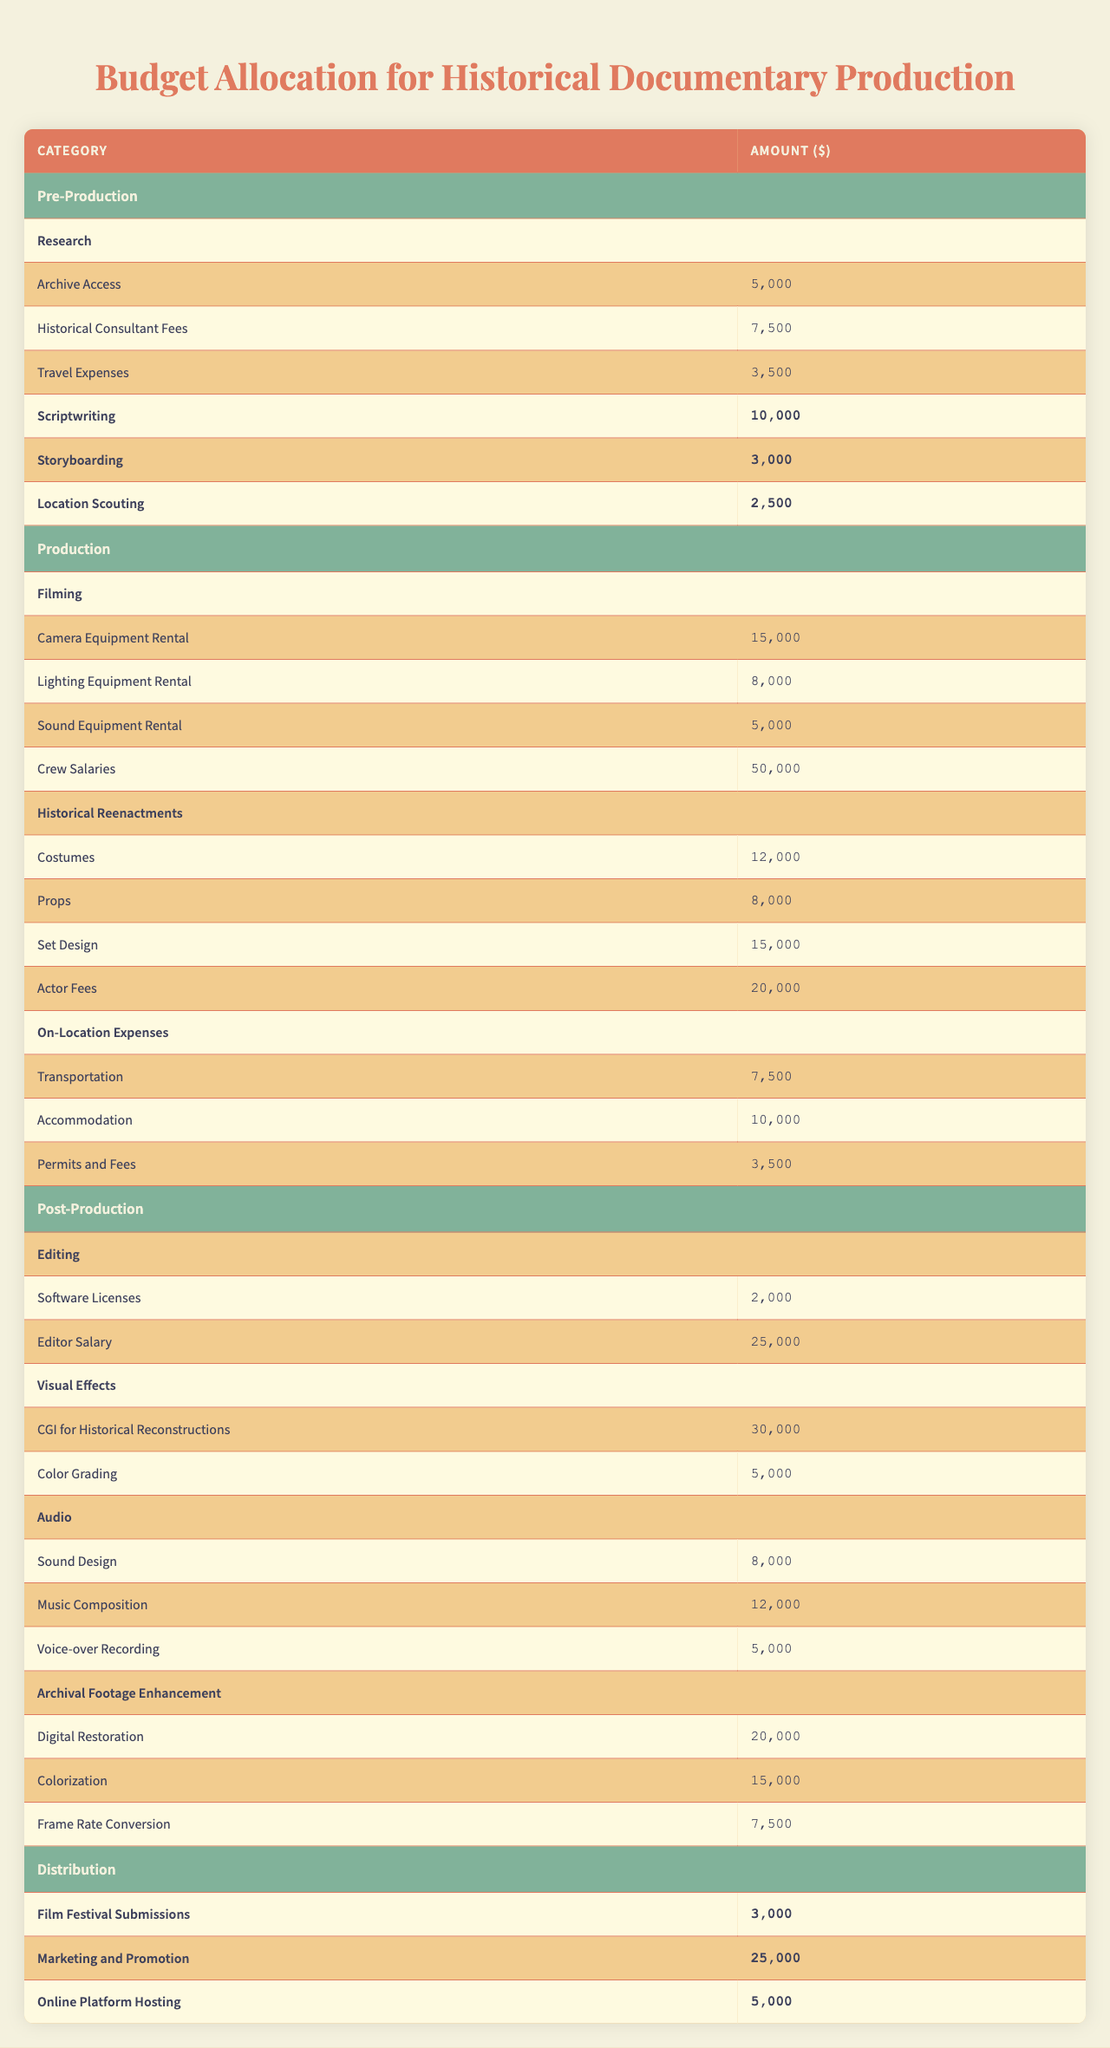What is the total budget allocated for Pre-Production? The budget for Pre-Production includes Research ($19,000), Scriptwriting ($10,000), Storyboarding ($3,000), and Location Scouting ($2,500). Adding these amounts gives us $34,500.
Answer: $34,500 How much is allocated for Crew Salaries in Production? The Crew Salaries under the Production category are specifically listed as $50,000.
Answer: $50,000 What is the cost of Historical Reenactments? The cost for Historical Reenactments includes Costumes ($12,000), Props ($8,000), Set Design ($15,000), and Actor Fees ($20,000). Summing these amounts gives $55,000.
Answer: $55,000 Which aspect has the highest budget allocation in Post-Production? The Archival Footage Enhancement category has the highest allocation with a total of $42,500. This includes Digital Restoration ($20,000), Colorization ($15,000), and Frame Rate Conversion ($7,500).
Answer: Archival Footage Enhancement Is the amount allocated for Marketing and Promotion greater than the total for Filming? The amount for Marketing and Promotion is $25,000, while the total for Filming (Camera Equipment Rental $15,000 + Lighting Equipment Rental $8,000 + Sound Equipment Rental $5,000 + Crew Salaries $50,000) sums to $78,000. Therefore, $25,000 is not greater than $78,000.
Answer: No What is the total budget allocated for the Distribution category? The Distribution category consists of Film Festival Submissions ($3,000), Marketing and Promotion ($25,000), and Online Platform Hosting ($5,000). Adding these values gives $33,000.
Answer: $33,000 How does the total amount for Editing compare to that of Visual Effects? The total amount for Editing (Software Licenses $2,000 + Editor Salary $25,000) is $27,000. For Visual Effects (CGI for Historical Reconstructions $30,000 + Color Grading $5,000), the total is $35,000. Since $27,000 is less than $35,000, Editing has a lower budget than Visual Effects.
Answer: Editing has a lower budget What is the average spending on Archival Footage Enhancement? In Archival Footage Enhancement, the total budget is $42,500 (Digital Restoration $20,000 + Colorization $15,000 + Frame Rate Conversion $7,500) with three components. The average is calculated as $42,500 divided by 3, resulting in approximately $14,167.
Answer: $14,167 Is the total budget for On-Location Expenses less than $25,000? The On-Location Expenses are Transportation ($7,500), Accommodation ($10,000), and Permits and Fees ($3,500). Summing these gives $21,000, which is indeed less than $25,000.
Answer: Yes What is the total budget for Production when including all categories? The total for Production includes Filming ($78,000: Crew Salaries $50,000 + Camera Equipment Rental $15,000 + Lighting Equipment Rental $8,000 + Sound Equipment Rental $5,000), Historical Reenactments ($55,000), and On-Location Expenses ($21,000). Adding these totals gives $154,000.
Answer: $154,000 